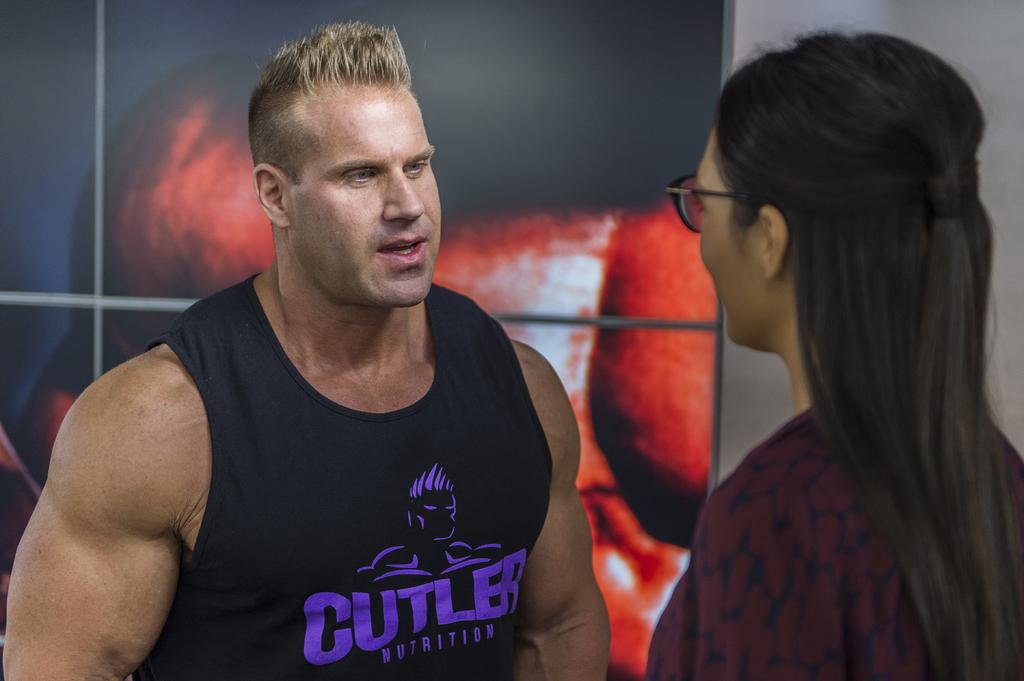<image>
Share a concise interpretation of the image provided. A muscular man in a black tank top that reads CUTLER NUTRITION 